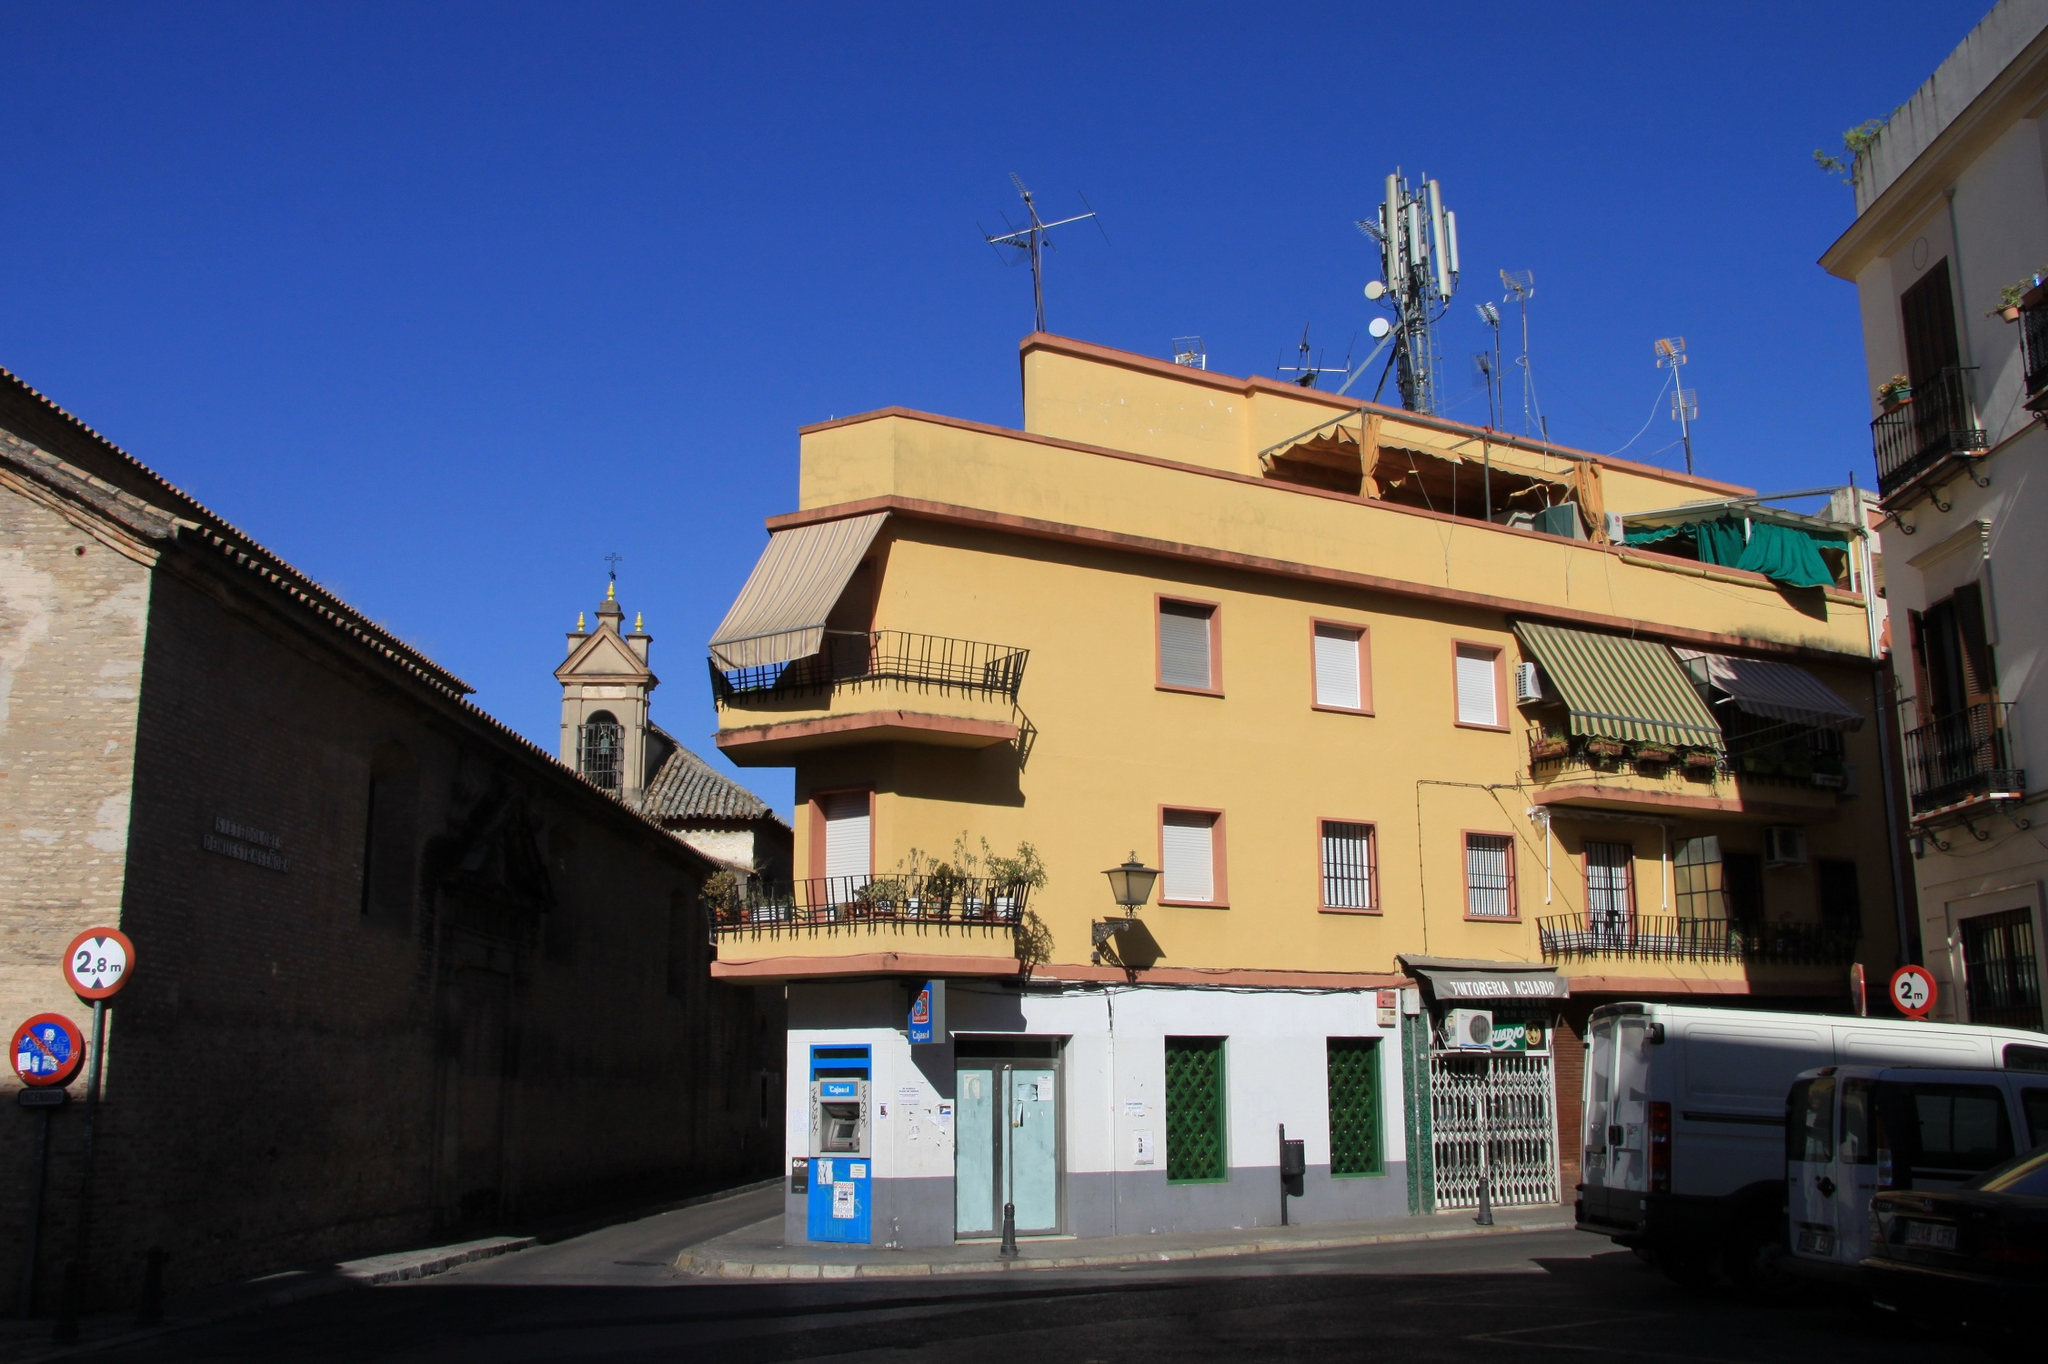Describe a short scenario involving a street artist painting near the yellow building. A street artist sets up an easel at the corner, captivated by the charm of the yellow building. With quick, confident strokes, they begin to paint, capturing the vivid hues under the morning sun. Passersby stop to admire the emerging artwork, a snapshot of everyday life immortalized on canvas. 